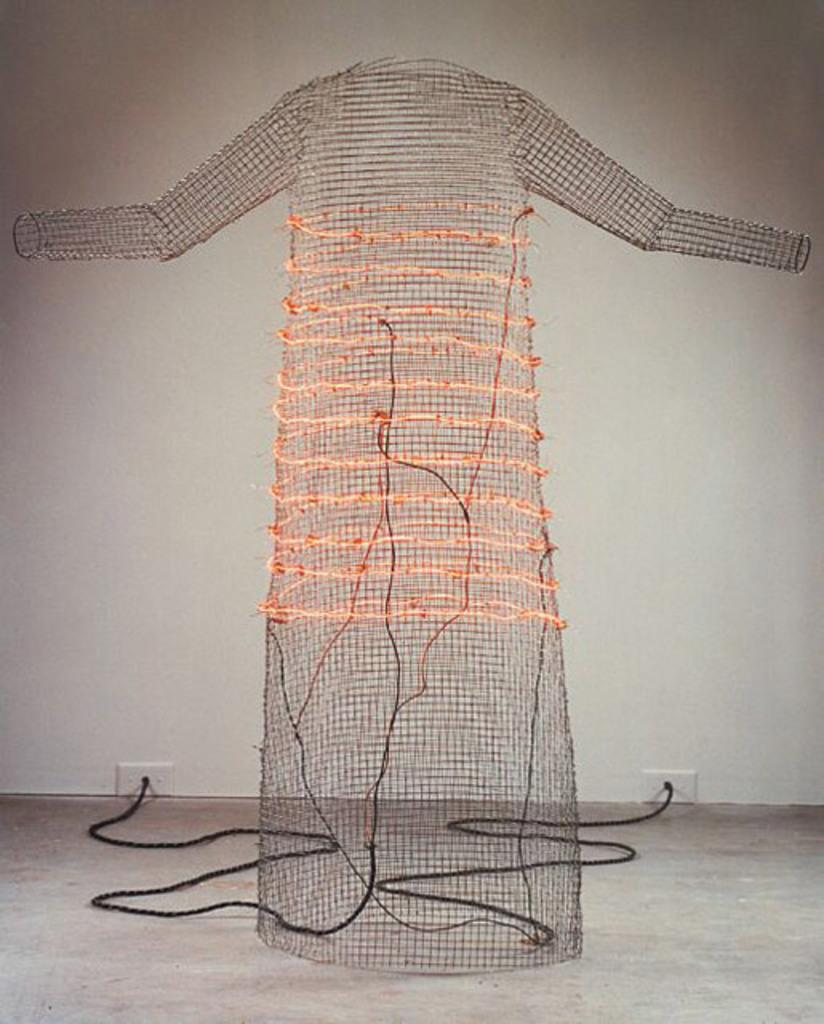What is the main subject of the image? The main subject of the image is a net that resembles a dress. Are there any additional features visible in the image? Yes, there are cables visible in the image. What can be seen in the background of the image? There is a wall in the background of the image. Can you describe the clouds in the image? There are no clouds present in the image; it features a net that resembles a dress, cables, and a wall in the background. How many men are visible in the image? There are no men present in the image. 